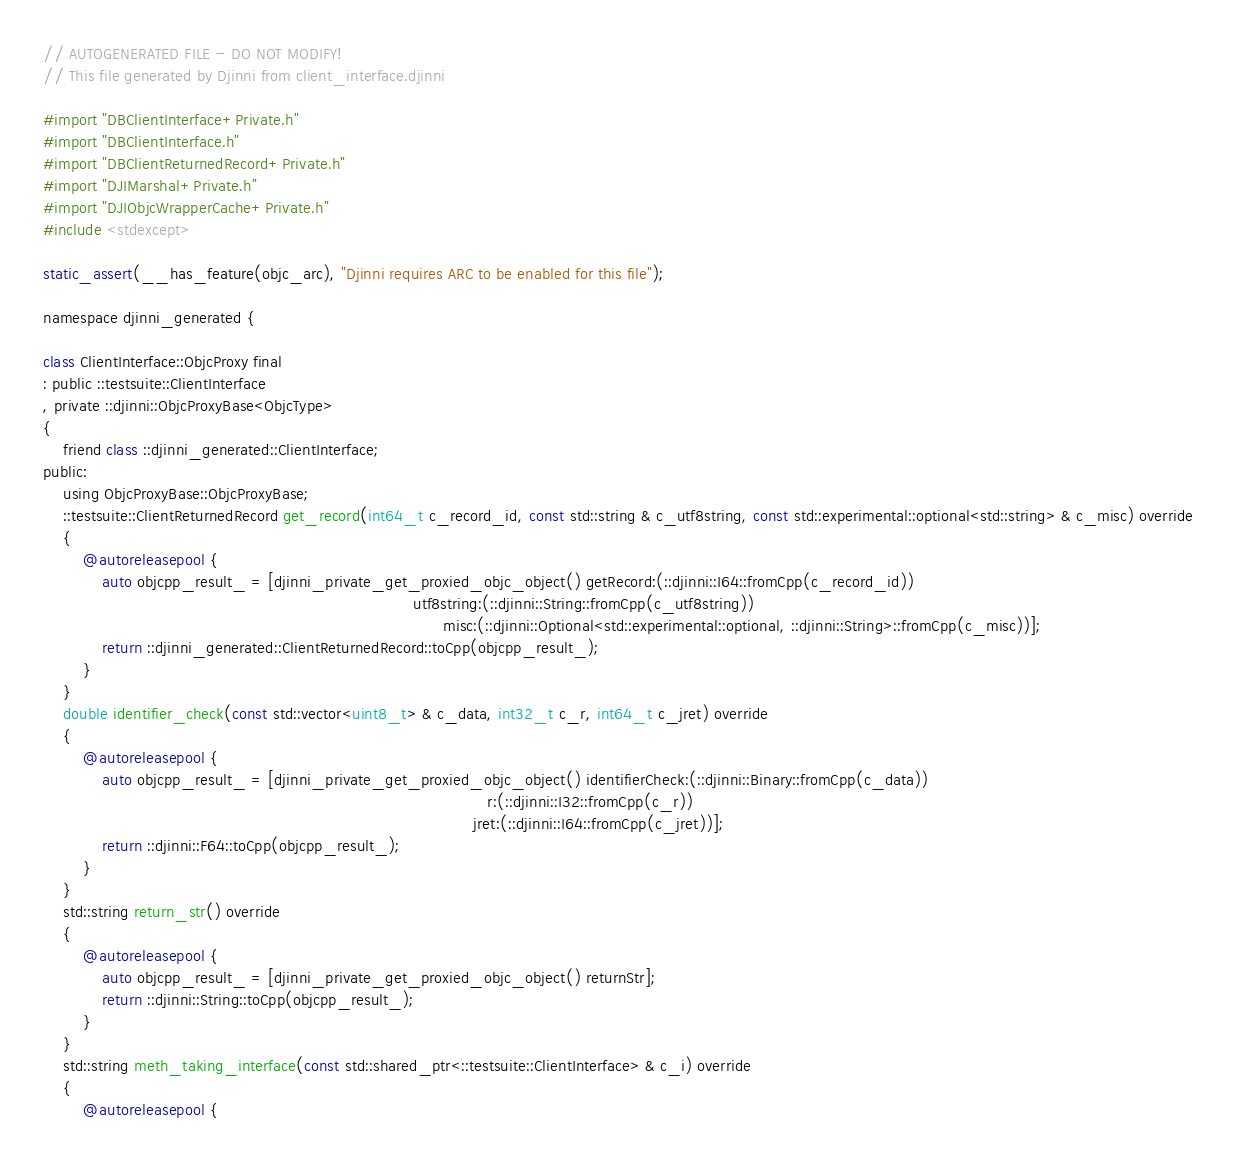<code> <loc_0><loc_0><loc_500><loc_500><_ObjectiveC_>// AUTOGENERATED FILE - DO NOT MODIFY!
// This file generated by Djinni from client_interface.djinni

#import "DBClientInterface+Private.h"
#import "DBClientInterface.h"
#import "DBClientReturnedRecord+Private.h"
#import "DJIMarshal+Private.h"
#import "DJIObjcWrapperCache+Private.h"
#include <stdexcept>

static_assert(__has_feature(objc_arc), "Djinni requires ARC to be enabled for this file");

namespace djinni_generated {

class ClientInterface::ObjcProxy final
: public ::testsuite::ClientInterface
, private ::djinni::ObjcProxyBase<ObjcType>
{
    friend class ::djinni_generated::ClientInterface;
public:
    using ObjcProxyBase::ObjcProxyBase;
    ::testsuite::ClientReturnedRecord get_record(int64_t c_record_id, const std::string & c_utf8string, const std::experimental::optional<std::string> & c_misc) override
    {
        @autoreleasepool {
            auto objcpp_result_ = [djinni_private_get_proxied_objc_object() getRecord:(::djinni::I64::fromCpp(c_record_id))
                                                                           utf8string:(::djinni::String::fromCpp(c_utf8string))
                                                                                 misc:(::djinni::Optional<std::experimental::optional, ::djinni::String>::fromCpp(c_misc))];
            return ::djinni_generated::ClientReturnedRecord::toCpp(objcpp_result_);
        }
    }
    double identifier_check(const std::vector<uint8_t> & c_data, int32_t c_r, int64_t c_jret) override
    {
        @autoreleasepool {
            auto objcpp_result_ = [djinni_private_get_proxied_objc_object() identifierCheck:(::djinni::Binary::fromCpp(c_data))
                                                                                          r:(::djinni::I32::fromCpp(c_r))
                                                                                       jret:(::djinni::I64::fromCpp(c_jret))];
            return ::djinni::F64::toCpp(objcpp_result_);
        }
    }
    std::string return_str() override
    {
        @autoreleasepool {
            auto objcpp_result_ = [djinni_private_get_proxied_objc_object() returnStr];
            return ::djinni::String::toCpp(objcpp_result_);
        }
    }
    std::string meth_taking_interface(const std::shared_ptr<::testsuite::ClientInterface> & c_i) override
    {
        @autoreleasepool {</code> 